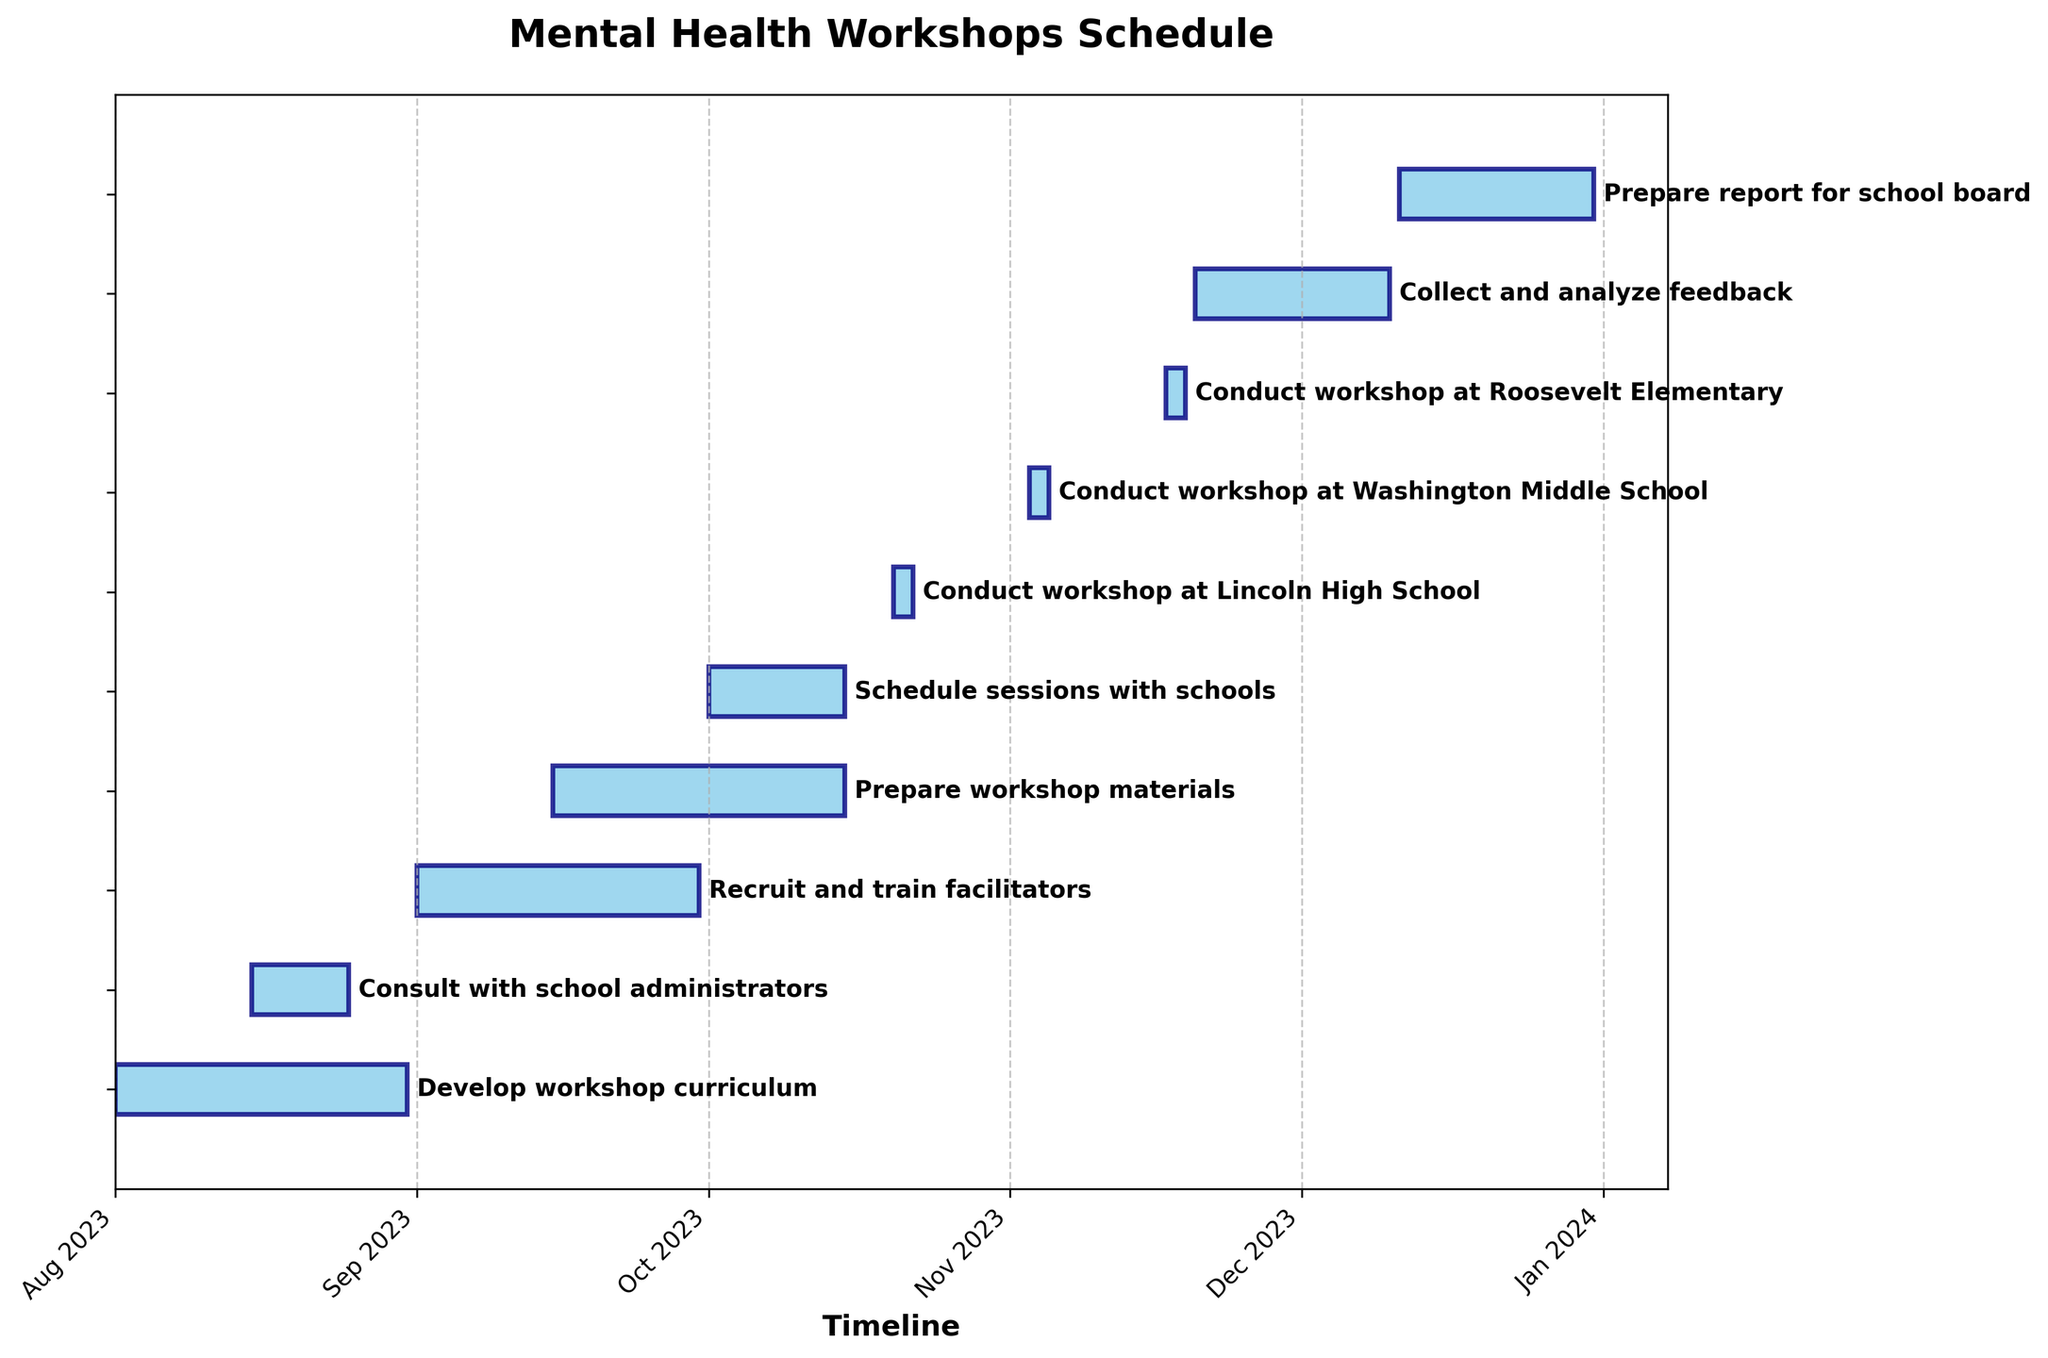What is the title of the chart? The title is located at the top of the chart, usually in a larger font size and often bolded to differentiate it from other text elements. In this figure, it reads 'Mental Health Workshops Schedule'.
Answer: Mental Health Workshops Schedule What color is used to represent the tasks on the Gantt chart? The visual cues indicate that the bars representing the tasks are colored in 'skyblue' with an 'navy' edge color. This color distinction helps to visually separate the tasks from the background and make the timeline clearer.
Answer: Skyblue with navy edges How long does it take to prepare workshop materials? To find out the duration, look at the length of the bar representing the task "Prepare workshop materials." The task starts on 2023-09-15 and ends on 2023-10-15, making the duration 31 days.
Answer: 31 days Which task follows immediately after scheduling sessions with schools? By tracing along the timeline, the task that starts right after "Schedule sessions with schools" is "Conduct workshop at Lincoln High School." This is determined by noting the position of the tasks along the time axis.
Answer: Conduct workshop at Lincoln High School What is the duration of the task that takes the longest to complete? Measure the lengths of all the bars representing different tasks. The task "Prepare workshop materials" and "Develop workshop curriculum" both have long durations of 31 days, but no other task exceeds this duration.
Answer: 31 days How many days are the workshops conducted at different schools? There are three separate tasks for conducting workshops: Lincoln High School, Washington Middle School, and Roosevelt Elementary. Each has a duration of 3 days as indicated next to the respective bars. Adding them gives 3 + 3 + 3 = 9 days.
Answer: 9 days Which task has the shortest span, and how many days does it span? Examining the lengths of all the bars, the "Consult with school administrators" is comparatively short. It spans from 2023-08-15 to 2023-08-25, totaling 11 days, which is the shortest duration among all tasks.
Answer: Consult with school administrators, 11 days What tasks are planned to overlap in September 2023? By examining the timeline for September, we see that "Recruit and train facilitators" overlaps with "Prepare workshop materials." Both of these tasks have bars extending into September.
Answer: Recruit and train facilitators, Prepare workshop materials When does the task "Collect and analyze feedback" start and end in relation to the last workshop? The last workshop (Roosevelt Elementary) ends on 2023-11-19. The "Collect and analyze feedback" task starts almost immediately after on 2023-11-20 and ends on 2023-12-10.
Answer: Starts the day after the last workshop, ends on 2023-12-10 